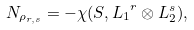<formula> <loc_0><loc_0><loc_500><loc_500>N _ { \rho _ { r , s } } = - \chi ( S , { L _ { 1 } } ^ { r } \otimes L _ { 2 } ^ { s } ) ,</formula> 